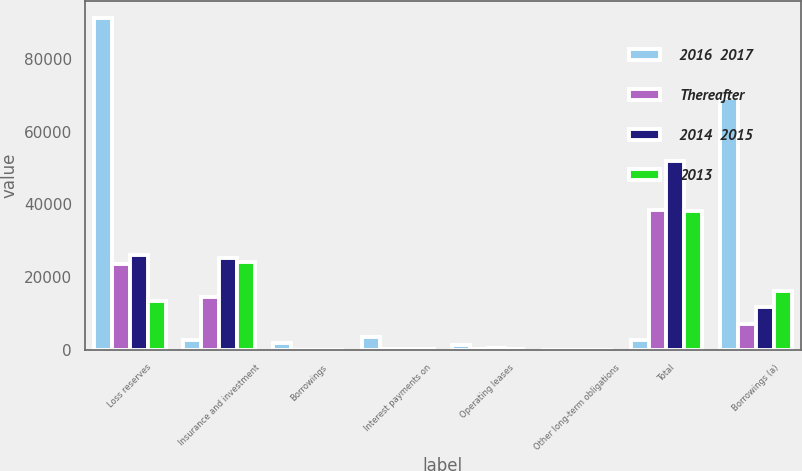<chart> <loc_0><loc_0><loc_500><loc_500><stacked_bar_chart><ecel><fcel>Loss reserves<fcel>Insurance and investment<fcel>Borrowings<fcel>Interest payments on<fcel>Operating leases<fcel>Other long-term obligations<fcel>Total<fcel>Borrowings (a)<nl><fcel>2016  2017<fcel>91237<fcel>2684<fcel>1843<fcel>3525<fcel>1196<fcel>37<fcel>2684<fcel>69166<nl><fcel>Thereafter<fcel>23579<fcel>14502<fcel>43<fcel>131<fcel>284<fcel>9<fcel>38548<fcel>7199<nl><fcel>2014  2015<fcel>26111<fcel>25144<fcel>15<fcel>264<fcel>390<fcel>14<fcel>51938<fcel>11670<nl><fcel>2013<fcel>13480<fcel>24066<fcel>8<fcel>265<fcel>276<fcel>8<fcel>38103<fcel>16104<nl></chart> 